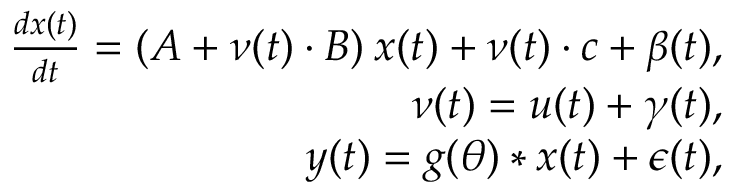Convert formula to latex. <formula><loc_0><loc_0><loc_500><loc_500>\begin{array} { r } { \frac { d x ( t ) } { d t } = ( A + \nu ( t ) \cdot B ) \, x ( t ) + \nu ( t ) \cdot c + \beta ( t ) , } \\ { \nu ( t ) = u ( t ) + \gamma ( t ) , } \\ { y ( t ) = g ( \theta ) * x ( t ) + \epsilon ( t ) , } \end{array}</formula> 